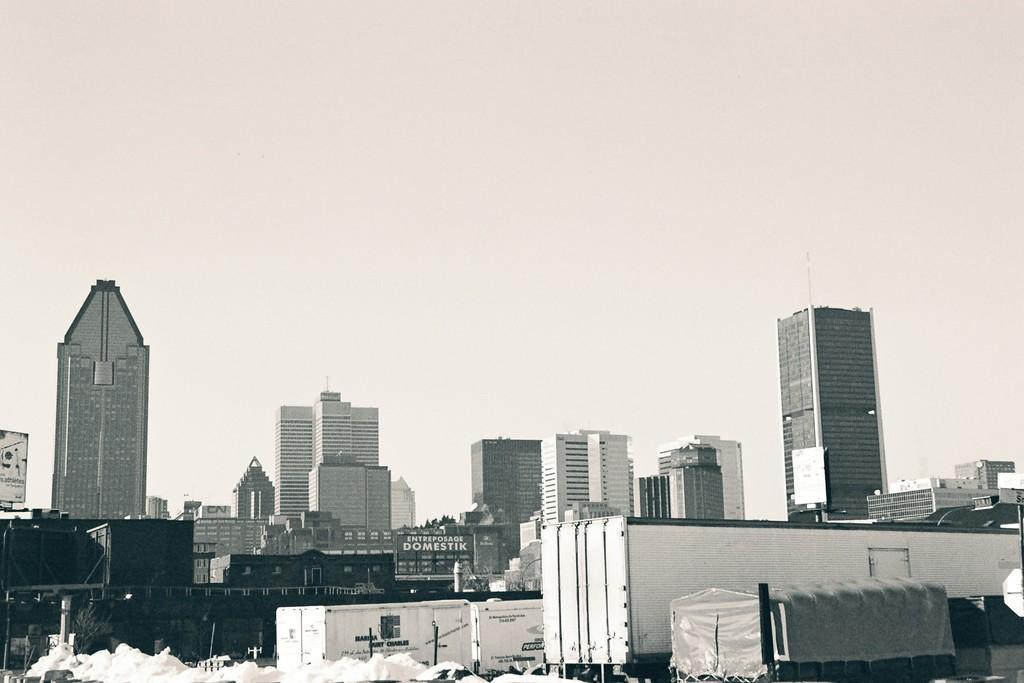Could you give a brief overview of what you see in this image? In this picture, it seems to be there are sacks and containers at the bottom side of the image and there are buildings in the background area of the image, there is a poster in the center of the image. 